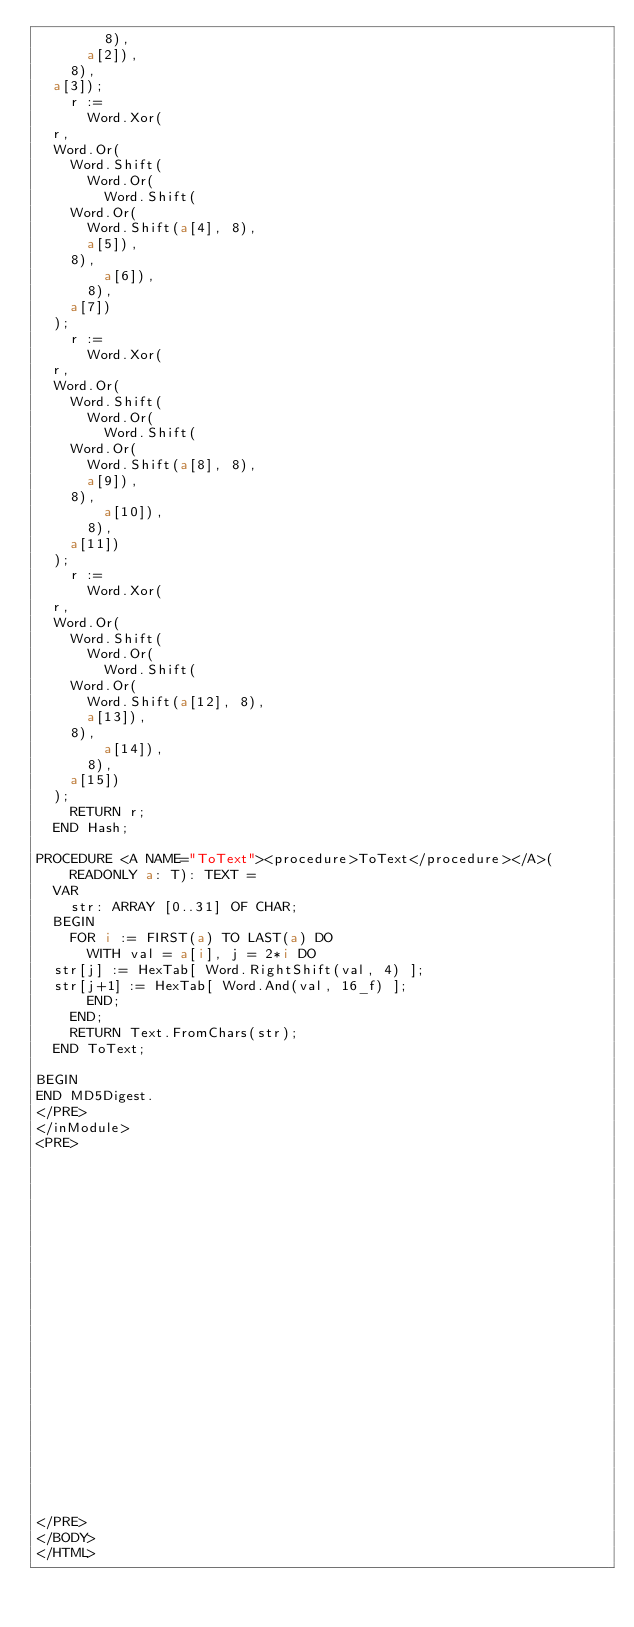<code> <loc_0><loc_0><loc_500><loc_500><_HTML_>	      8),
	    a[2]),
	  8),
	a[3]);
    r :=
      Word.Xor(
	r,
	Word.Or(
	  Word.Shift(
	    Word.Or(
	      Word.Shift(
		Word.Or(
		  Word.Shift(a[4], 8),
		  a[5]),
		8),
	      a[6]),
	    8),
	  a[7])
	);
    r :=
      Word.Xor(
	r,
	Word.Or(
	  Word.Shift(
	    Word.Or(
	      Word.Shift(
		Word.Or(
		  Word.Shift(a[8], 8),
		  a[9]),
		8),
	      a[10]),
	    8),
	  a[11])
	);
    r :=
      Word.Xor(
	r,
	Word.Or(
	  Word.Shift(
	    Word.Or(
	      Word.Shift(
		Word.Or(
		  Word.Shift(a[12], 8),
		  a[13]),
		8),
	      a[14]),
	    8),
	  a[15])
	);
    RETURN r;
  END Hash;

PROCEDURE <A NAME="ToText"><procedure>ToText</procedure></A>(READONLY a: T): TEXT =
  VAR
    str: ARRAY [0..31] OF CHAR;
  BEGIN
    FOR i := FIRST(a) TO LAST(a) DO
      WITH val = a[i], j = 2*i DO
	str[j] := HexTab[ Word.RightShift(val, 4) ];
	str[j+1] := HexTab[ Word.And(val, 16_f) ];
      END;
    END;
    RETURN Text.FromChars(str);
  END ToText;

BEGIN
END MD5Digest.
</PRE>
</inModule>
<PRE>























</PRE>
</BODY>
</HTML>
</code> 